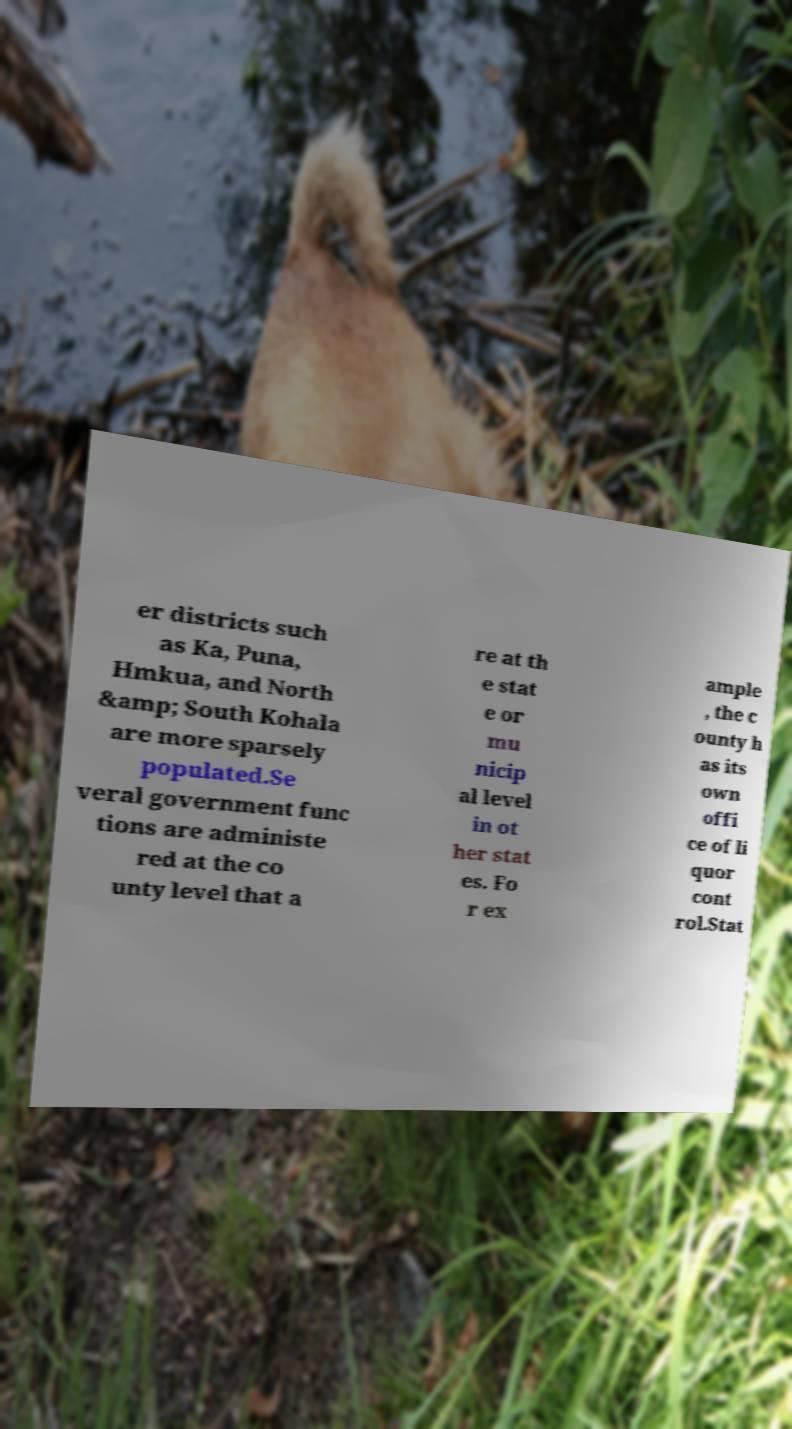For documentation purposes, I need the text within this image transcribed. Could you provide that? er districts such as Ka, Puna, Hmkua, and North &amp; South Kohala are more sparsely populated.Se veral government func tions are administe red at the co unty level that a re at th e stat e or mu nicip al level in ot her stat es. Fo r ex ample , the c ounty h as its own offi ce of li quor cont rol.Stat 